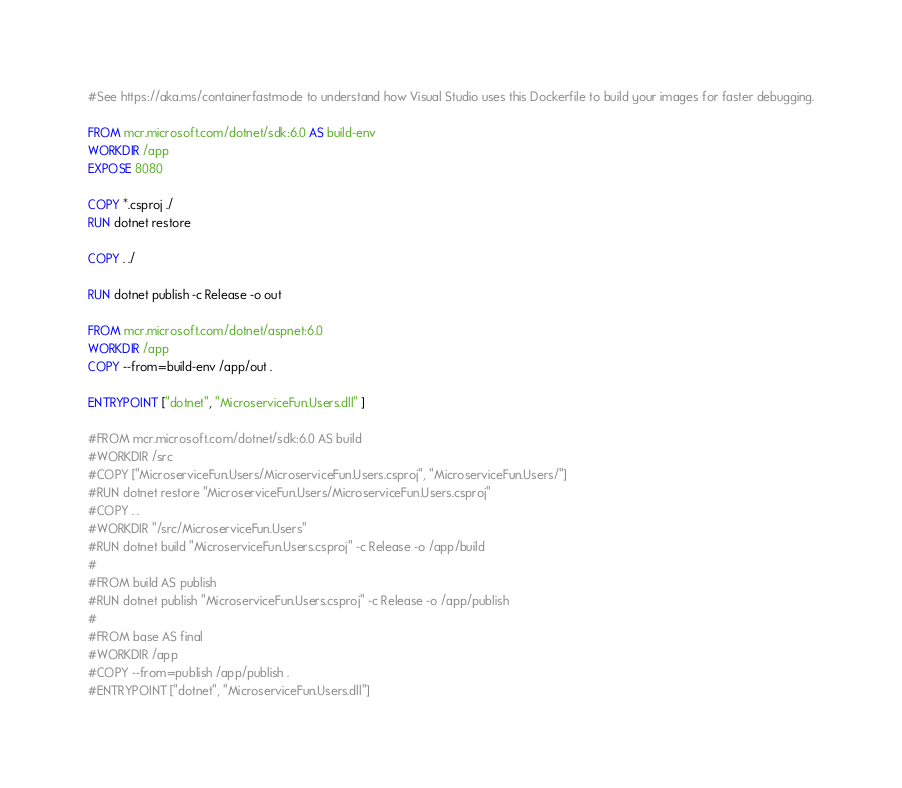Convert code to text. <code><loc_0><loc_0><loc_500><loc_500><_Dockerfile_>#See https://aka.ms/containerfastmode to understand how Visual Studio uses this Dockerfile to build your images for faster debugging.

FROM mcr.microsoft.com/dotnet/sdk:6.0 AS build-env
WORKDIR /app
EXPOSE 8080

COPY *.csproj ./
RUN dotnet restore

COPY . ./

RUN dotnet publish -c Release -o out

FROM mcr.microsoft.com/dotnet/aspnet:6.0
WORKDIR /app
COPY --from=build-env /app/out .

ENTRYPOINT ["dotnet", "MicroserviceFun.Users.dll" ]

#FROM mcr.microsoft.com/dotnet/sdk:6.0 AS build
#WORKDIR /src
#COPY ["MicroserviceFun.Users/MicroserviceFun.Users.csproj", "MicroserviceFun.Users/"]
#RUN dotnet restore "MicroserviceFun.Users/MicroserviceFun.Users.csproj"
#COPY . .
#WORKDIR "/src/MicroserviceFun.Users"
#RUN dotnet build "MicroserviceFun.Users.csproj" -c Release -o /app/build
#
#FROM build AS publish
#RUN dotnet publish "MicroserviceFun.Users.csproj" -c Release -o /app/publish
#
#FROM base AS final
#WORKDIR /app
#COPY --from=publish /app/publish .
#ENTRYPOINT ["dotnet", "MicroserviceFun.Users.dll"]</code> 